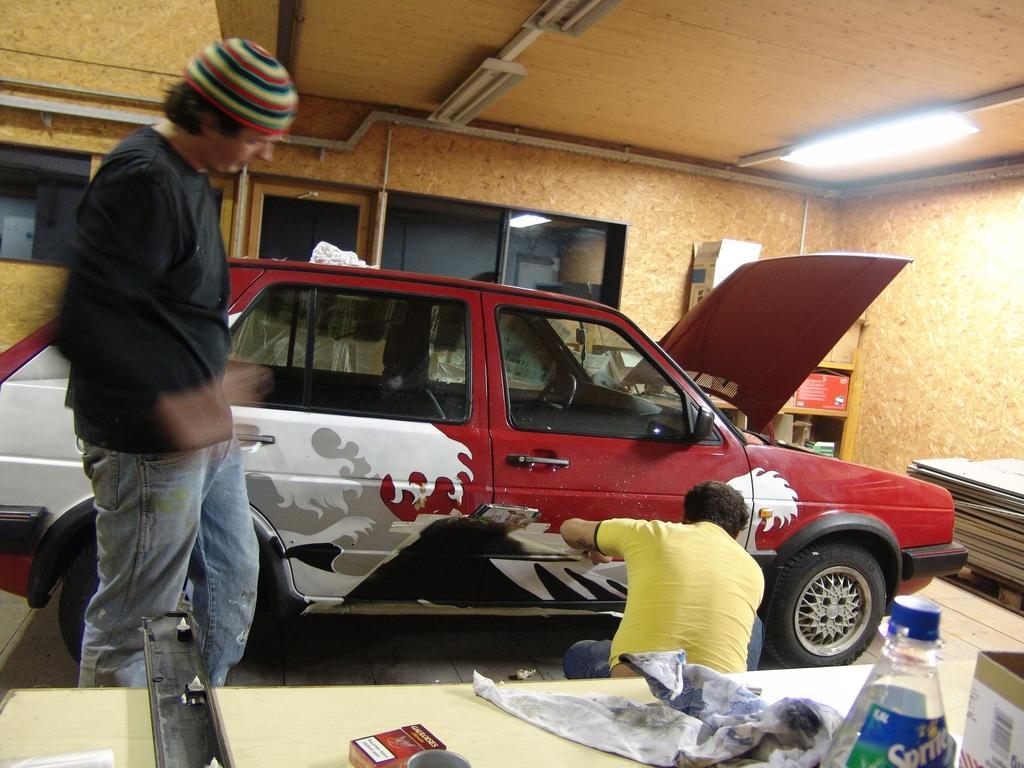Could you give a brief overview of what you see in this image? Here we see a man stickering car and we see another man, standing and looking at and we see a table 